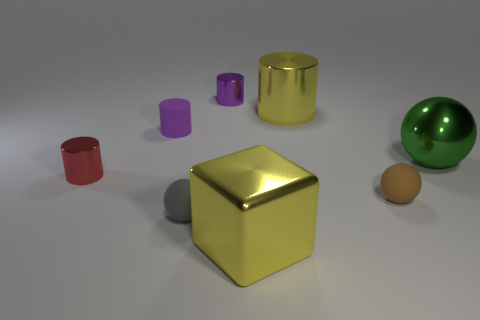There is a tiny metal cylinder behind the yellow metal object behind the tiny rubber thing behind the brown thing; what is its color?
Provide a succinct answer. Purple. Is the color of the large block the same as the large metal cylinder?
Provide a short and direct response. Yes. What number of shiny objects are both left of the big green metallic sphere and in front of the purple matte object?
Keep it short and to the point. 2. What number of rubber things are either small cylinders or tiny gray things?
Provide a short and direct response. 2. The tiny sphere left of the small purple cylinder that is behind the small purple rubber cylinder is made of what material?
Make the answer very short. Rubber. There is a metal object that is the same color as the big cylinder; what is its shape?
Make the answer very short. Cube. There is a purple object that is the same size as the purple metallic cylinder; what shape is it?
Offer a very short reply. Cylinder. Is the number of big cylinders less than the number of yellow shiny objects?
Offer a terse response. Yes. Is there a shiny sphere that is on the left side of the cube that is in front of the small brown thing?
Make the answer very short. No. What is the shape of the big green object that is made of the same material as the small red cylinder?
Give a very brief answer. Sphere. 